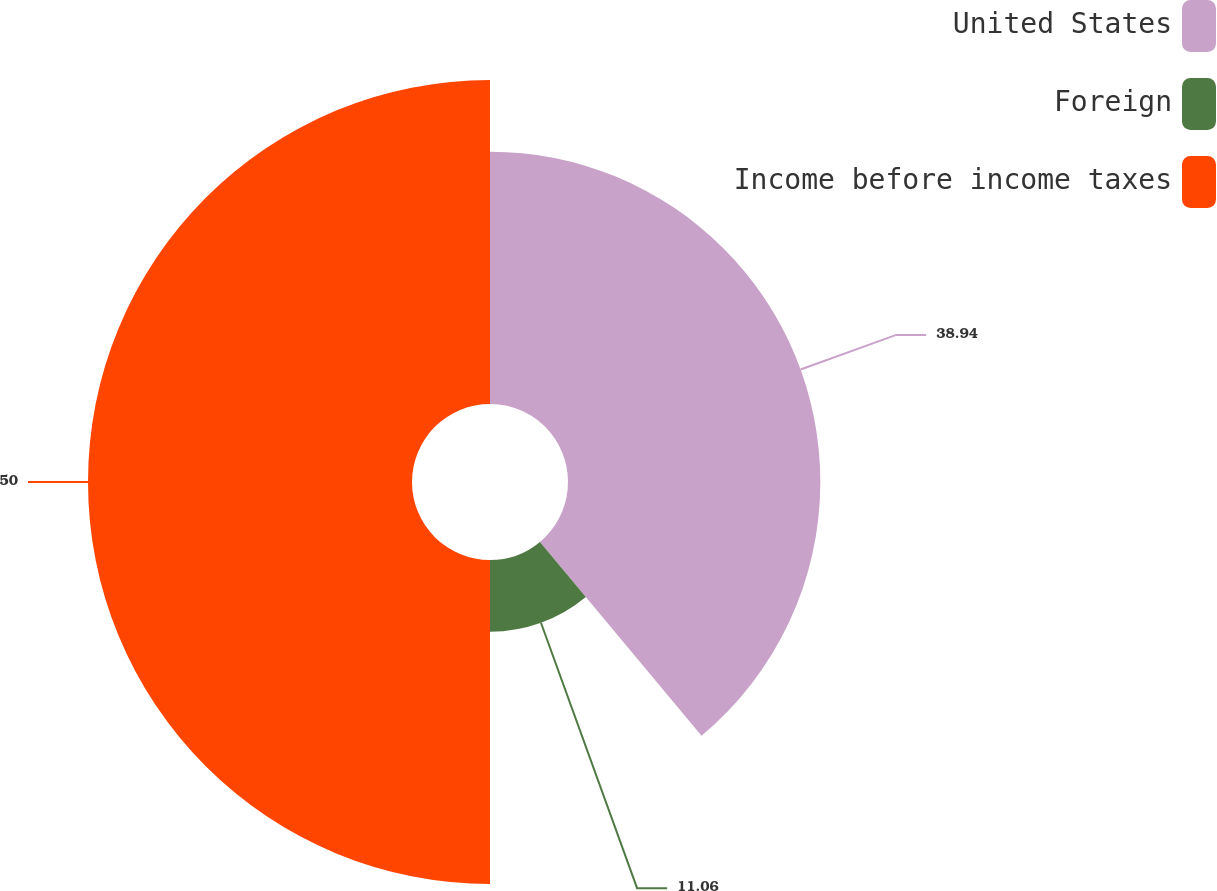<chart> <loc_0><loc_0><loc_500><loc_500><pie_chart><fcel>United States<fcel>Foreign<fcel>Income before income taxes<nl><fcel>38.94%<fcel>11.06%<fcel>50.0%<nl></chart> 